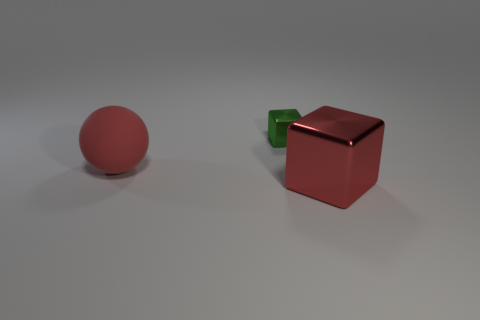Add 2 small shiny things. How many objects exist? 5 Subtract all blocks. How many objects are left? 1 Add 1 tiny things. How many tiny things exist? 2 Subtract 0 cyan cubes. How many objects are left? 3 Subtract all tiny green metal things. Subtract all big metallic cubes. How many objects are left? 1 Add 2 big red metal objects. How many big red metal objects are left? 3 